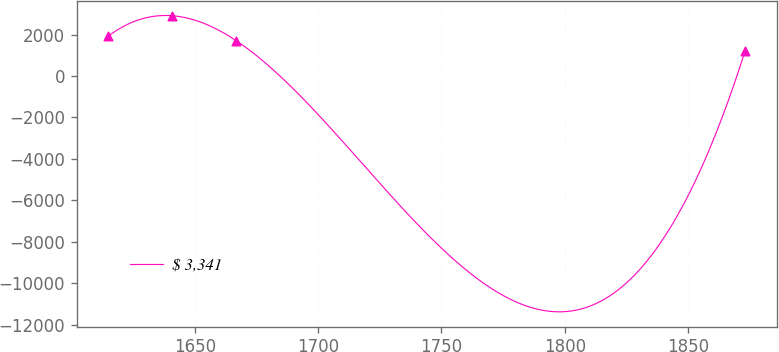Convert chart. <chart><loc_0><loc_0><loc_500><loc_500><line_chart><ecel><fcel>$ 3,341<nl><fcel>1614.95<fcel>1933.07<nl><fcel>1640.78<fcel>2913.42<nl><fcel>1666.86<fcel>1700.75<nl><fcel>1873.22<fcel>1233.8<nl></chart> 